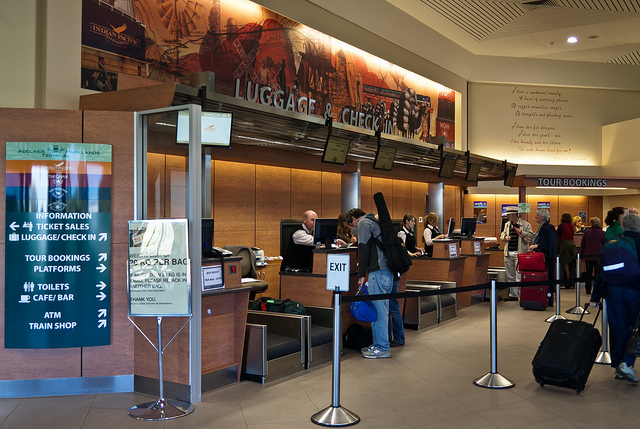How many people are there? 2 